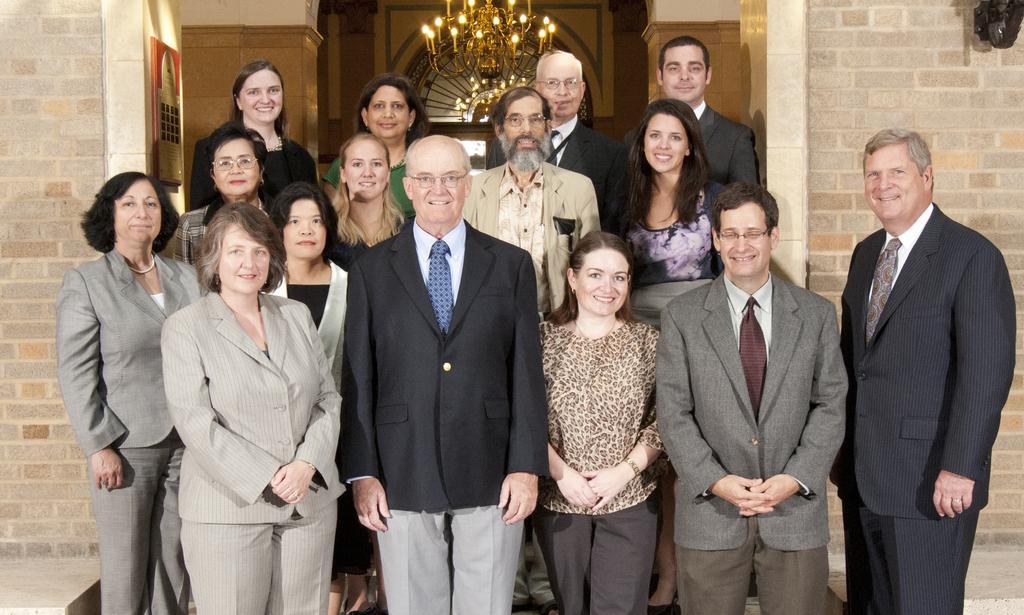In one or two sentences, can you explain what this image depicts? In the front of the image we can see a group of people are standing and smiling. In the background there are walls, board, chandelier and glass. Board is on the wall.   